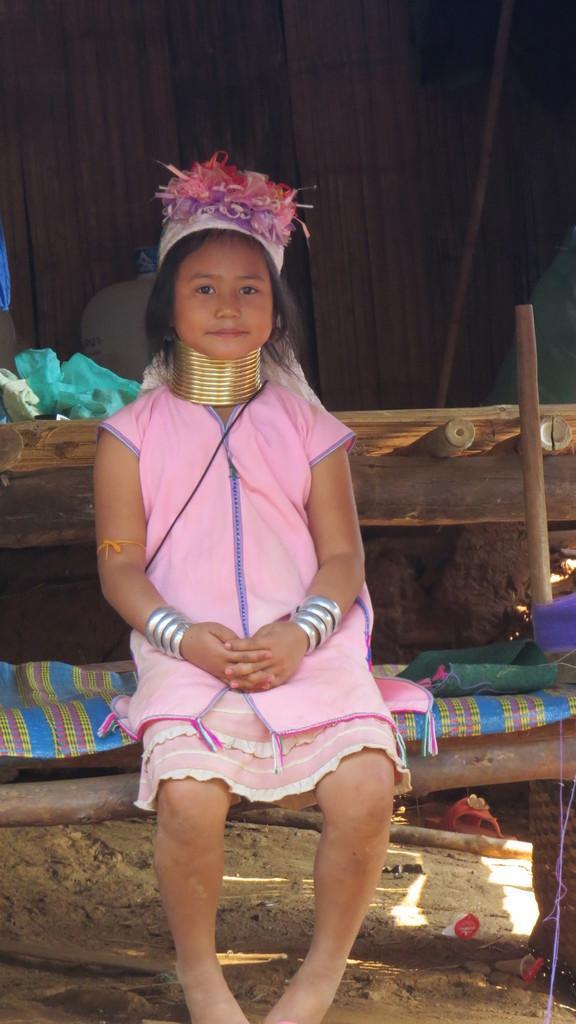Could you give a brief overview of what you see in this image? In this image we can see a girl sitting on a wooden bed and wearing objects, we can see a wooden wall in the background. 